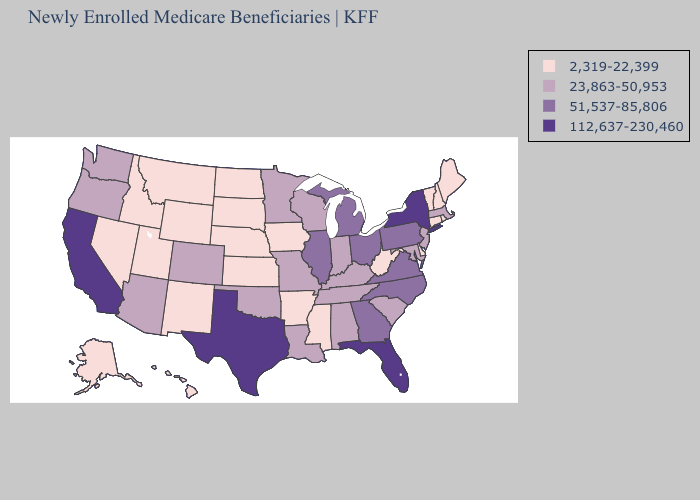Does Washington have the same value as New Mexico?
Be succinct. No. What is the lowest value in the South?
Concise answer only. 2,319-22,399. What is the value of Louisiana?
Keep it brief. 23,863-50,953. Name the states that have a value in the range 112,637-230,460?
Quick response, please. California, Florida, New York, Texas. What is the value of Arkansas?
Write a very short answer. 2,319-22,399. What is the highest value in states that border Arizona?
Quick response, please. 112,637-230,460. Does Vermont have a higher value than West Virginia?
Short answer required. No. Which states have the lowest value in the USA?
Give a very brief answer. Alaska, Arkansas, Connecticut, Delaware, Hawaii, Idaho, Iowa, Kansas, Maine, Mississippi, Montana, Nebraska, Nevada, New Hampshire, New Mexico, North Dakota, Rhode Island, South Dakota, Utah, Vermont, West Virginia, Wyoming. Which states hav the highest value in the South?
Be succinct. Florida, Texas. Among the states that border California , does Nevada have the highest value?
Short answer required. No. Does Connecticut have the same value as Missouri?
Give a very brief answer. No. Is the legend a continuous bar?
Be succinct. No. Does Arizona have a lower value than New Hampshire?
Concise answer only. No. What is the value of South Carolina?
Short answer required. 23,863-50,953. Does the map have missing data?
Write a very short answer. No. 